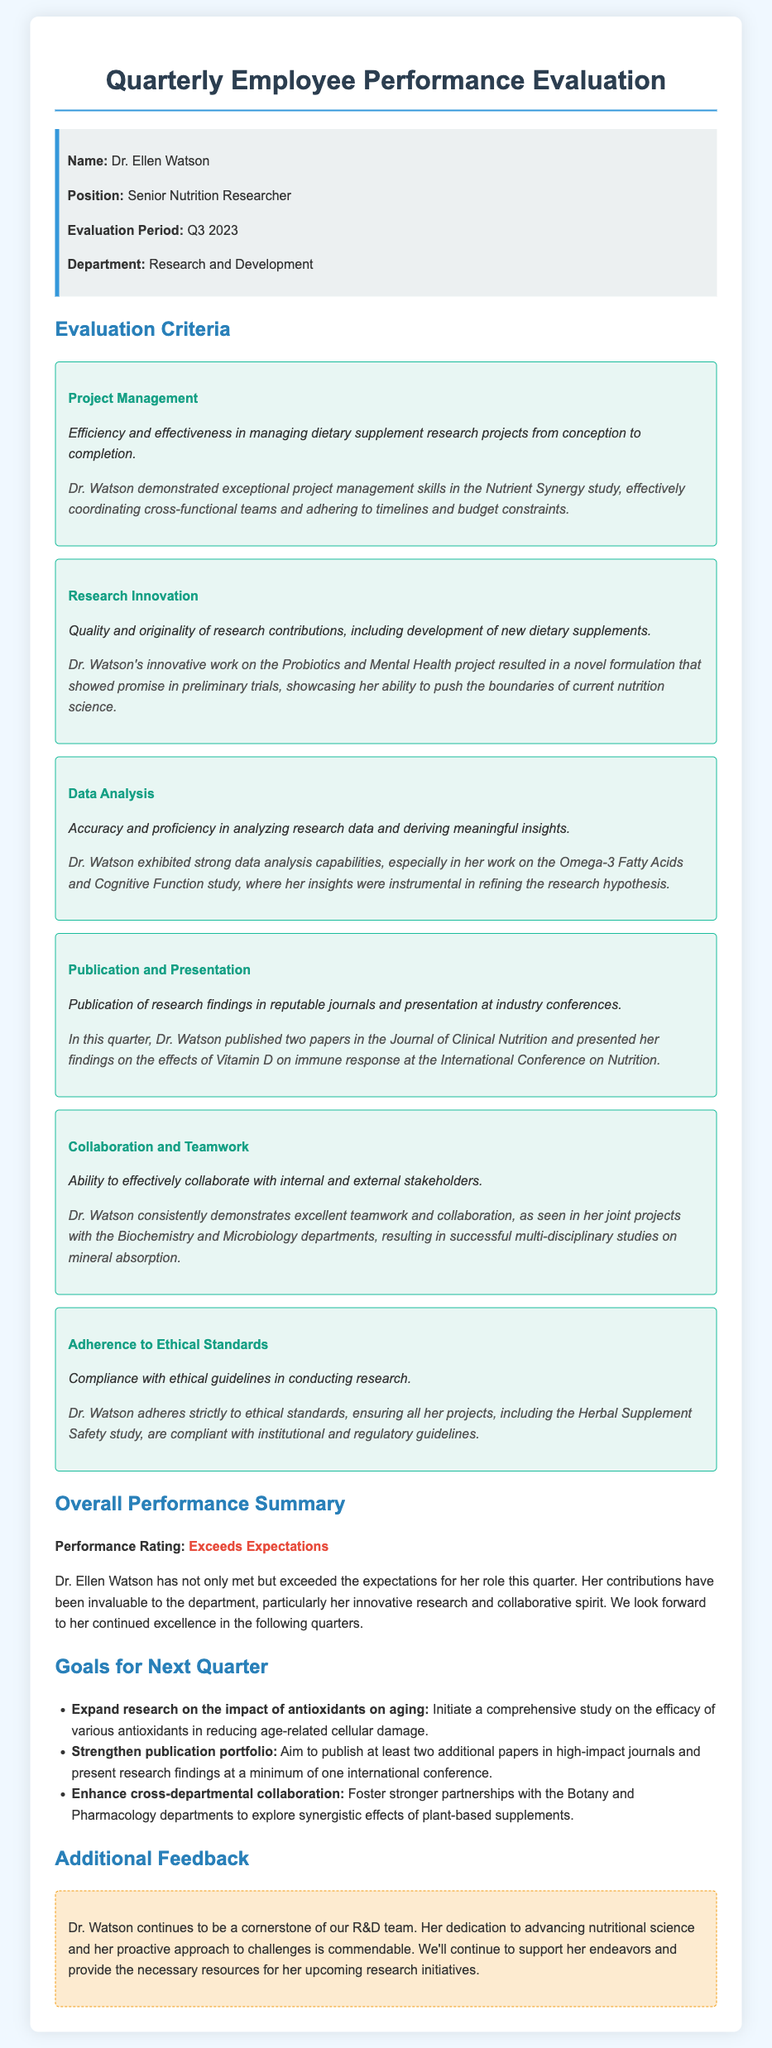What is the name of the employee evaluated? The name of the employee evaluated is mentioned at the beginning of the document.
Answer: Dr. Ellen Watson What is Dr. Watson's position? Dr. Watson's position is specified in the info box section of the document.
Answer: Senior Nutrition Researcher What period does this evaluation cover? The evaluation period is clearly listed in the info box.
Answer: Q3 2023 How many papers did Dr. Watson publish this quarter? The number of papers published is stated in the Publication and Presentation section.
Answer: Two What was the performance rating given to Dr. Watson? The performance rating appears in the Overall Performance Summary.
Answer: Exceeds Expectations Which study did Dr. Watson coordinate effectively? The specific study is mentioned under Project Management in the document.
Answer: Nutrient Synergy study What is one goal for the next quarter? The goals for the next quarter are listed, including various research topics.
Answer: Expand research on the impact of antioxidants on aging In which journal were Dr. Watson's two papers published? The document indicates the journal where her papers appeared.
Answer: Journal of Clinical Nutrition What area of collaboration is emphasized for the next quarter? The document outlines a specific area for enhancing collaboration in the goals section.
Answer: Botany and Pharmacology departments 